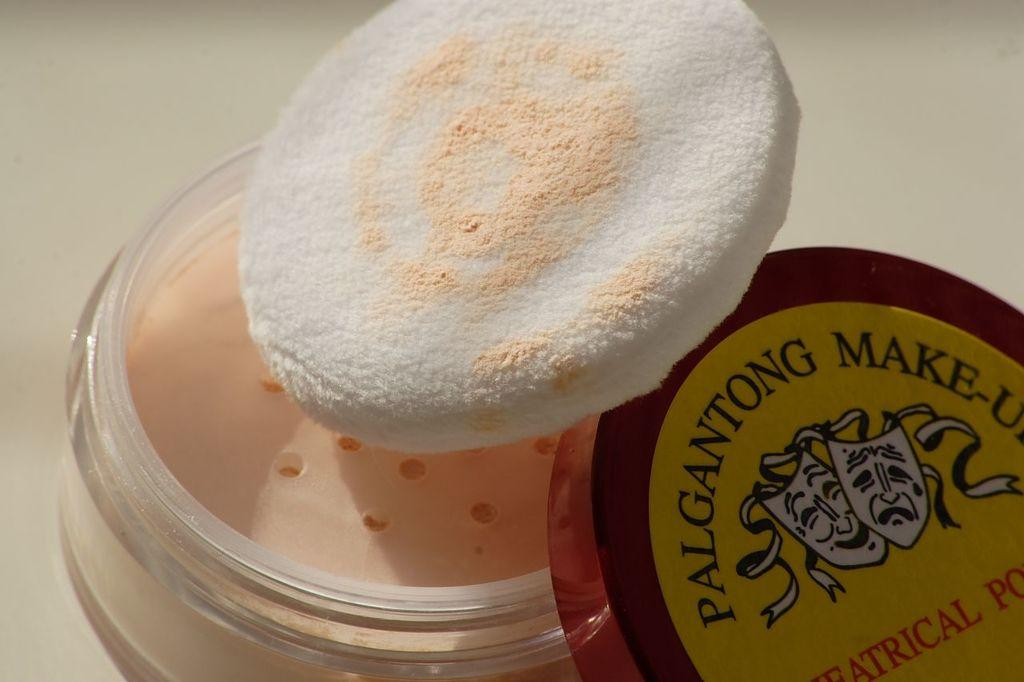What is the main piece of furniture in the image? There is a table in the image. What is placed on the table? There is a makeup box and a puff on the table. What type of straw is used to blend the makeup in the image? There is no straw present in the image, and the makeup is not being blended. 